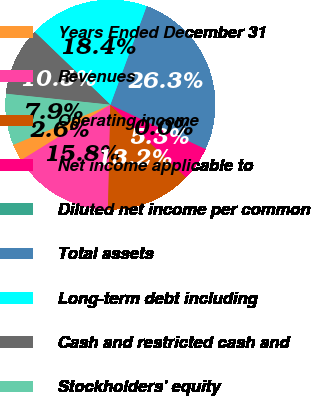Convert chart to OTSL. <chart><loc_0><loc_0><loc_500><loc_500><pie_chart><fcel>Years Ended December 31<fcel>Revenues<fcel>Operating income<fcel>Net income applicable to<fcel>Diluted net income per common<fcel>Total assets<fcel>Long-term debt including<fcel>Cash and restricted cash and<fcel>Stockholders' equity<nl><fcel>2.63%<fcel>15.79%<fcel>13.16%<fcel>5.26%<fcel>0.0%<fcel>26.32%<fcel>18.42%<fcel>10.53%<fcel>7.89%<nl></chart> 